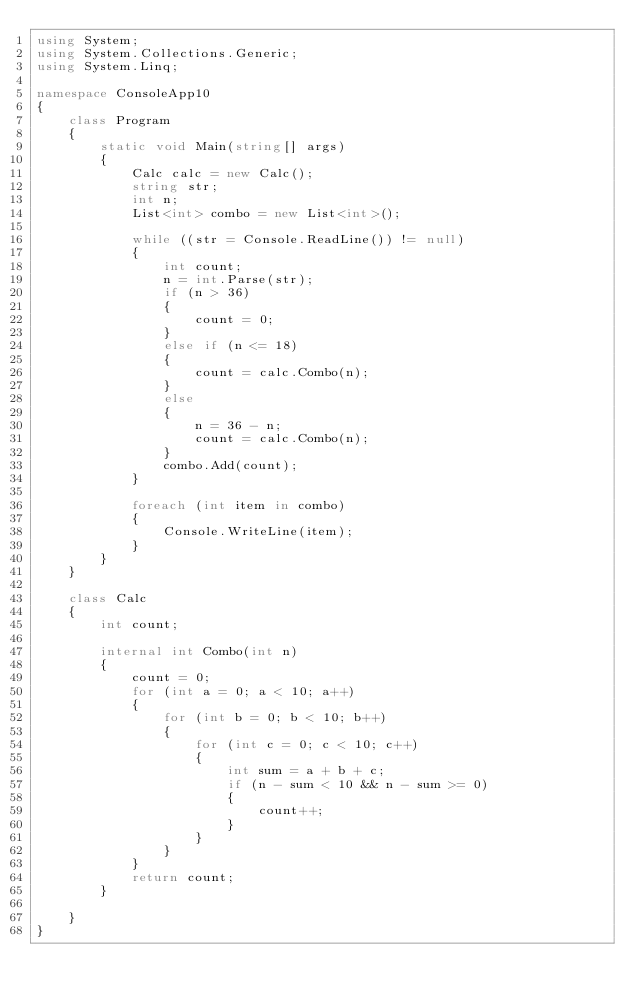Convert code to text. <code><loc_0><loc_0><loc_500><loc_500><_C#_>using System;
using System.Collections.Generic;
using System.Linq;

namespace ConsoleApp10
{
    class Program
    {
        static void Main(string[] args)
        {
            Calc calc = new Calc();
            string str;
            int n;
            List<int> combo = new List<int>();

            while ((str = Console.ReadLine()) != null)
            {
                int count;
                n = int.Parse(str);
                if (n > 36)
                {
                    count = 0;
                }
                else if (n <= 18)
                {
                    count = calc.Combo(n);
                }
                else
                {
                    n = 36 - n;
                    count = calc.Combo(n);
                }
                combo.Add(count);
            }

            foreach (int item in combo)
            {
                Console.WriteLine(item);
            }
        }
    }

    class Calc
    {
        int count;

        internal int Combo(int n)
        {
            count = 0;
            for (int a = 0; a < 10; a++)
            {
                for (int b = 0; b < 10; b++)
                {
                    for (int c = 0; c < 10; c++)
                    {
                        int sum = a + b + c;
                        if (n - sum < 10 && n - sum >= 0)
                        {
                            count++;
                        }
                    }
                }
            }
            return count;
        }

    }
}

</code> 